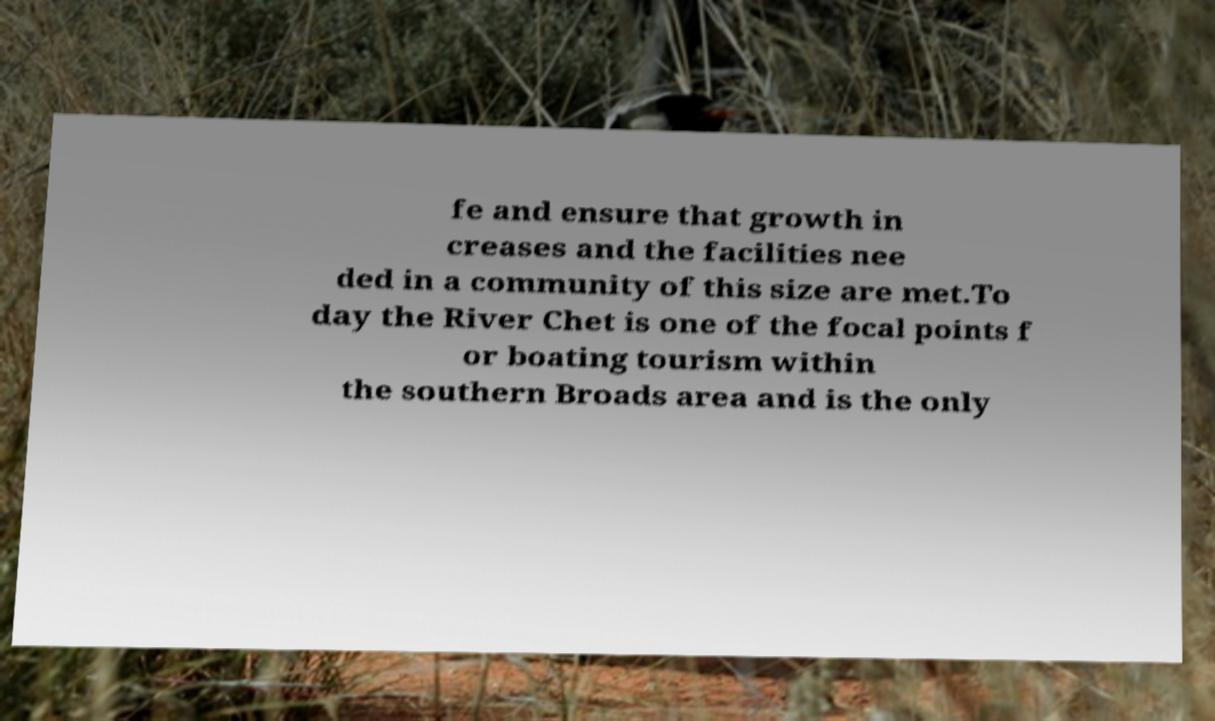There's text embedded in this image that I need extracted. Can you transcribe it verbatim? fe and ensure that growth in creases and the facilities nee ded in a community of this size are met.To day the River Chet is one of the focal points f or boating tourism within the southern Broads area and is the only 